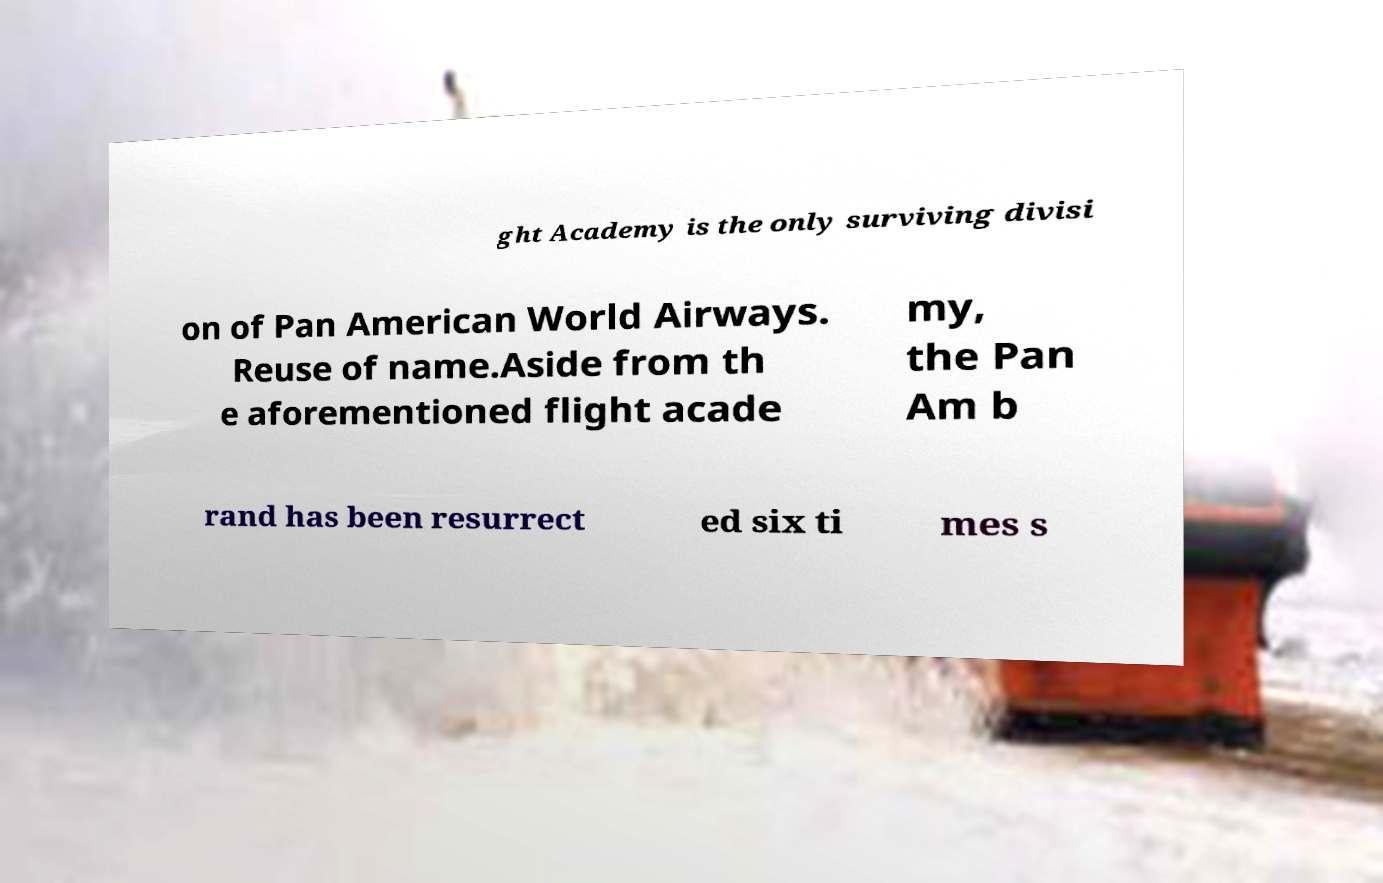I need the written content from this picture converted into text. Can you do that? ght Academy is the only surviving divisi on of Pan American World Airways. Reuse of name.Aside from th e aforementioned flight acade my, the Pan Am b rand has been resurrect ed six ti mes s 